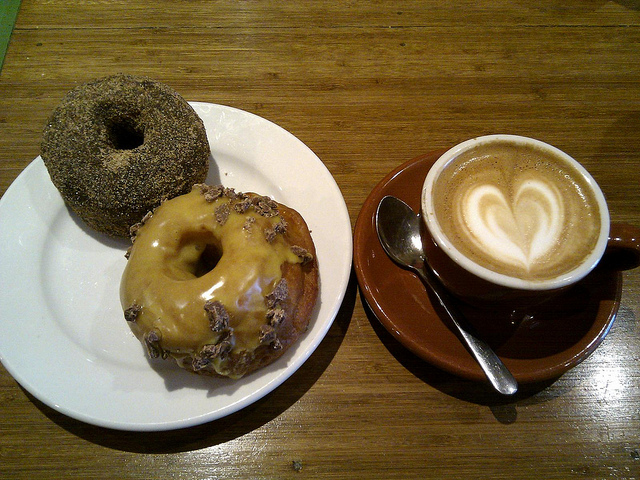What time of day do you think this meal is best suited for? This meal, with its freshly brewed cappuccino and indulgent doughnuts, seems perfect for a leisurely breakfast or as a mid-morning treat. The heart-shaped latte art suggests a touch of care, ideal for starting the day on a positive note. 